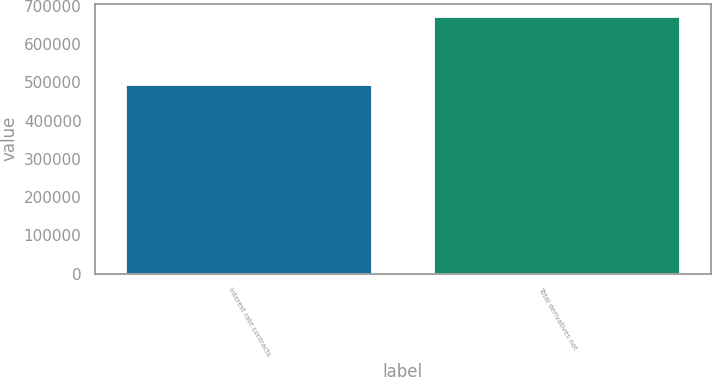Convert chart to OTSL. <chart><loc_0><loc_0><loc_500><loc_500><bar_chart><fcel>Interest rate contracts<fcel>Total derivatives not<nl><fcel>493173<fcel>670867<nl></chart> 